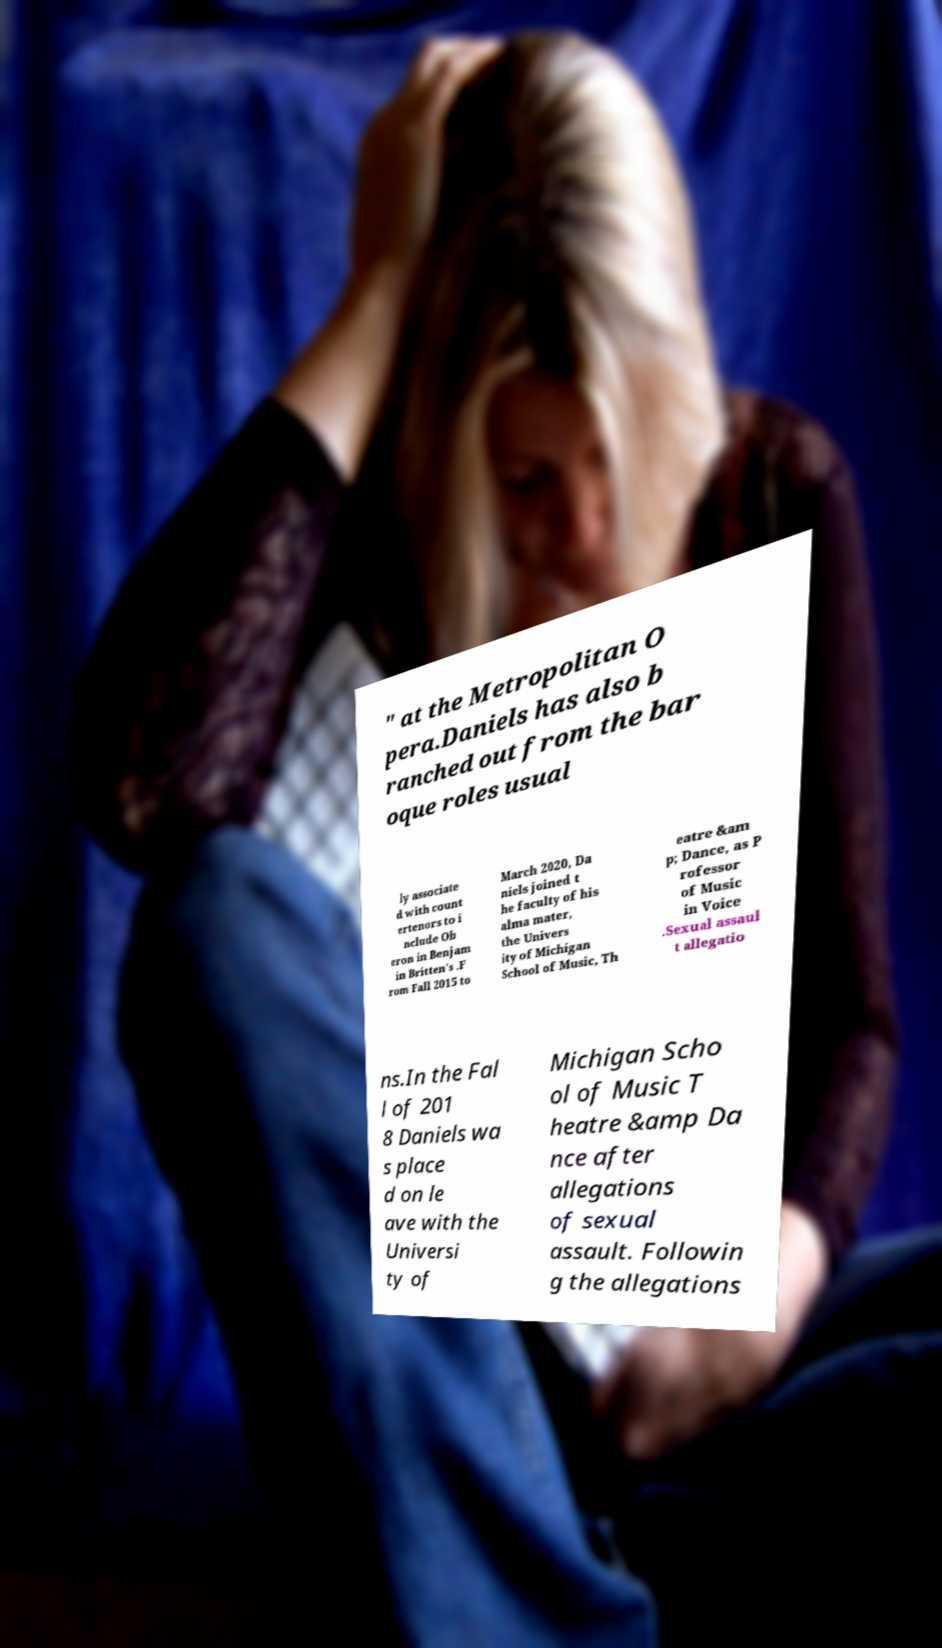Can you read and provide the text displayed in the image?This photo seems to have some interesting text. Can you extract and type it out for me? " at the Metropolitan O pera.Daniels has also b ranched out from the bar oque roles usual ly associate d with count ertenors to i nclude Ob eron in Benjam in Britten's .F rom Fall 2015 to March 2020, Da niels joined t he faculty of his alma mater, the Univers ity of Michigan School of Music, Th eatre &am p; Dance, as P rofessor of Music in Voice .Sexual assaul t allegatio ns.In the Fal l of 201 8 Daniels wa s place d on le ave with the Universi ty of Michigan Scho ol of Music T heatre &amp Da nce after allegations of sexual assault. Followin g the allegations 